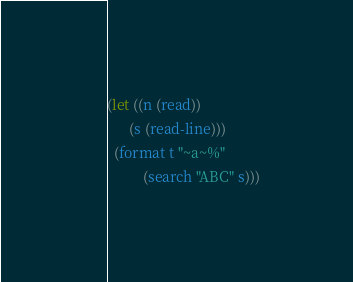<code> <loc_0><loc_0><loc_500><loc_500><_Lisp_>(let ((n (read))
      (s (read-line)))
  (format t "~a~%"
          (search "ABC" s)))</code> 